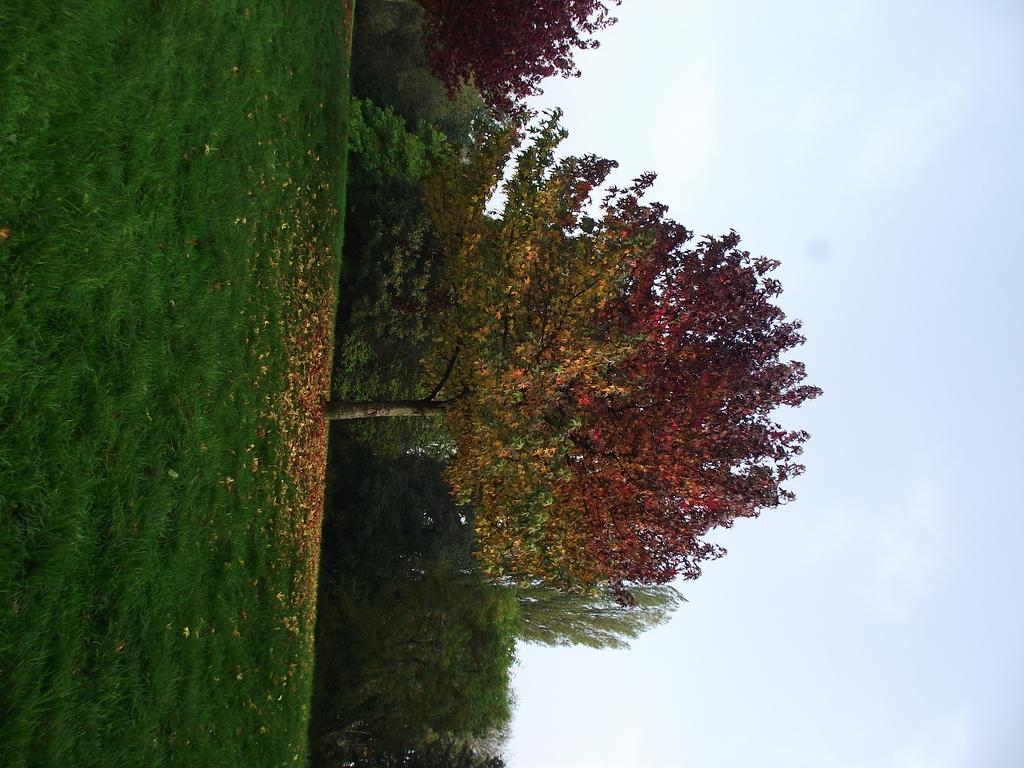What type of vegetation can be seen in the image? There are trees and grass in the image. What else can be found on the ground in the image? There are dried leaves in the image. What is visible in the background of the image? The sky is visible in the image. What type of stew is being prepared in the image? There is no stew present in the image; it features trees, grass, dried leaves, and the sky. What magical powers do the trees possess in the image? The trees in the image do not possess any magical powers, as they are depicted in a natural setting. 